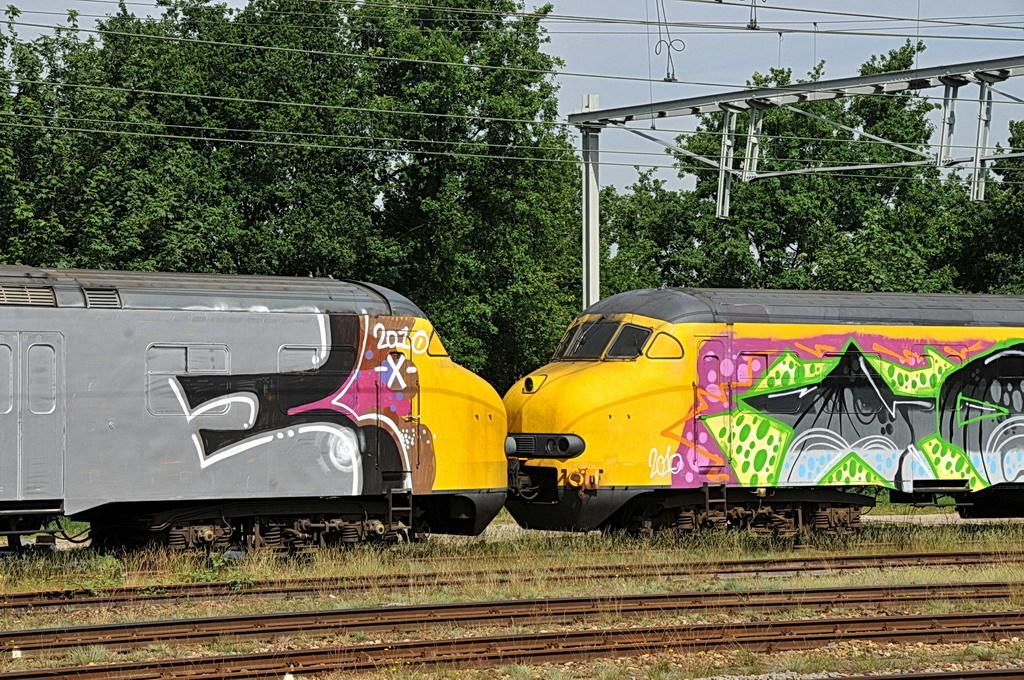How many trains can be seen in the image? There are two trains in the image. Where are the trains located? The trains are on railway tracks. What can be seen in the background of the image? There are trees in the background of the image. What is present in the top right corner of the image? Electric wires and a pole are present in the top right corner of the image. What type of activity is the doll participating in with the trains in the image? There is no doll present in the image, so no such activity can be observed. 